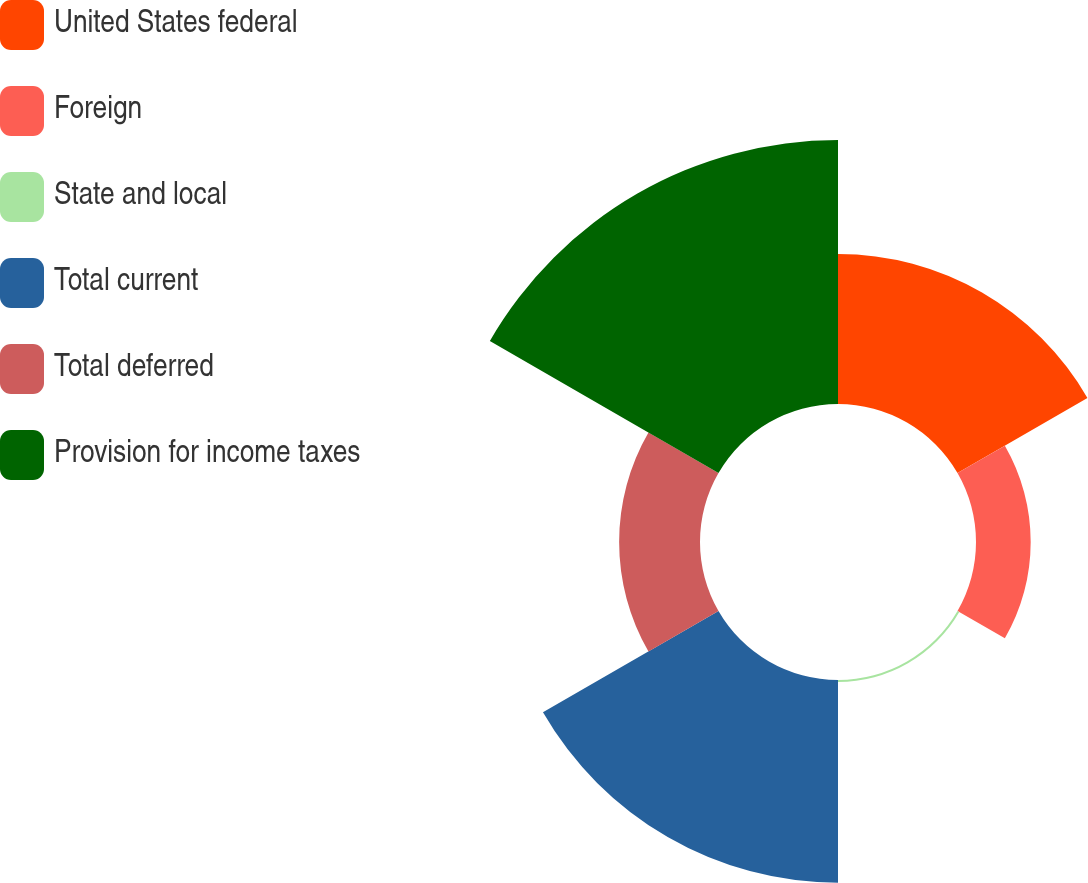Convert chart to OTSL. <chart><loc_0><loc_0><loc_500><loc_500><pie_chart><fcel>United States federal<fcel>Foreign<fcel>State and local<fcel>Total current<fcel>Total deferred<fcel>Provision for income taxes<nl><fcel>19.89%<fcel>7.25%<fcel>0.27%<fcel>26.87%<fcel>10.72%<fcel>35.0%<nl></chart> 